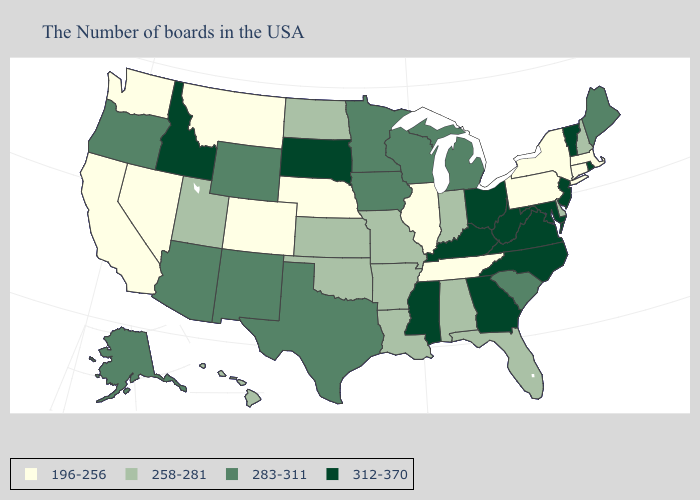Name the states that have a value in the range 258-281?
Quick response, please. New Hampshire, Delaware, Florida, Indiana, Alabama, Louisiana, Missouri, Arkansas, Kansas, Oklahoma, North Dakota, Utah, Hawaii. Name the states that have a value in the range 312-370?
Give a very brief answer. Rhode Island, Vermont, New Jersey, Maryland, Virginia, North Carolina, West Virginia, Ohio, Georgia, Kentucky, Mississippi, South Dakota, Idaho. Does Nebraska have a higher value than Connecticut?
Be succinct. No. Name the states that have a value in the range 312-370?
Quick response, please. Rhode Island, Vermont, New Jersey, Maryland, Virginia, North Carolina, West Virginia, Ohio, Georgia, Kentucky, Mississippi, South Dakota, Idaho. Does the first symbol in the legend represent the smallest category?
Answer briefly. Yes. Name the states that have a value in the range 312-370?
Quick response, please. Rhode Island, Vermont, New Jersey, Maryland, Virginia, North Carolina, West Virginia, Ohio, Georgia, Kentucky, Mississippi, South Dakota, Idaho. What is the value of Maryland?
Write a very short answer. 312-370. Among the states that border Colorado , does Nebraska have the lowest value?
Keep it brief. Yes. What is the highest value in the Northeast ?
Be succinct. 312-370. Does the map have missing data?
Short answer required. No. What is the value of Connecticut?
Be succinct. 196-256. Name the states that have a value in the range 196-256?
Be succinct. Massachusetts, Connecticut, New York, Pennsylvania, Tennessee, Illinois, Nebraska, Colorado, Montana, Nevada, California, Washington. What is the value of Kentucky?
Be succinct. 312-370. What is the highest value in states that border Iowa?
Be succinct. 312-370. 